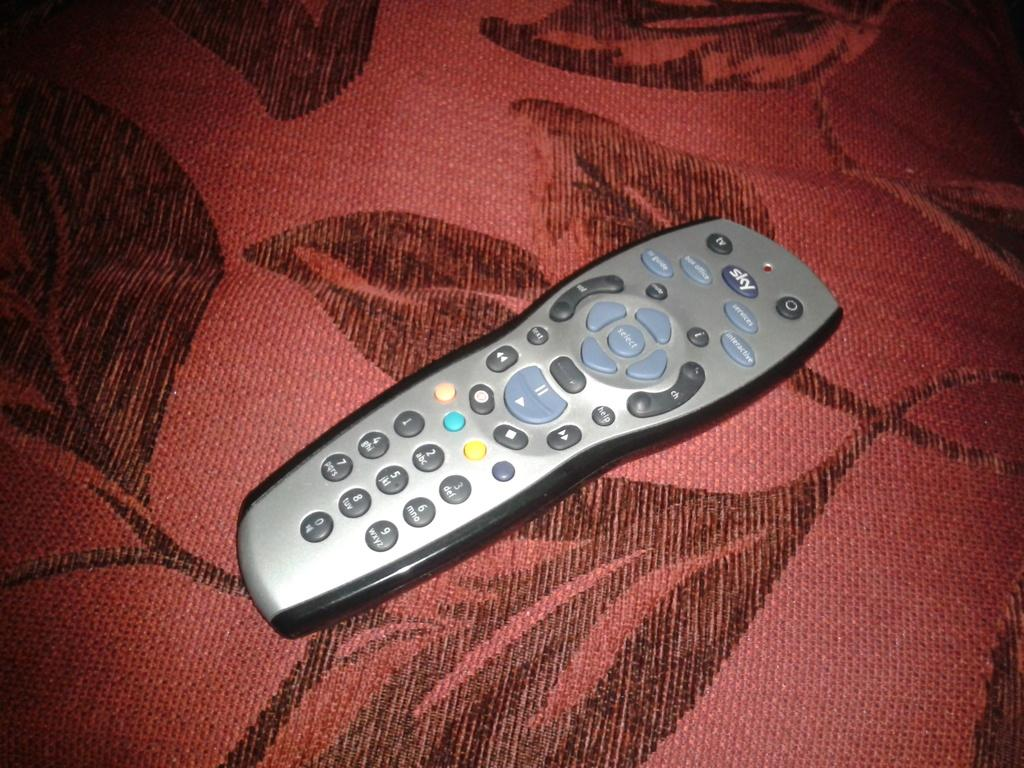<image>
Summarize the visual content of the image. Remote controller with a large SKY button near the top. 